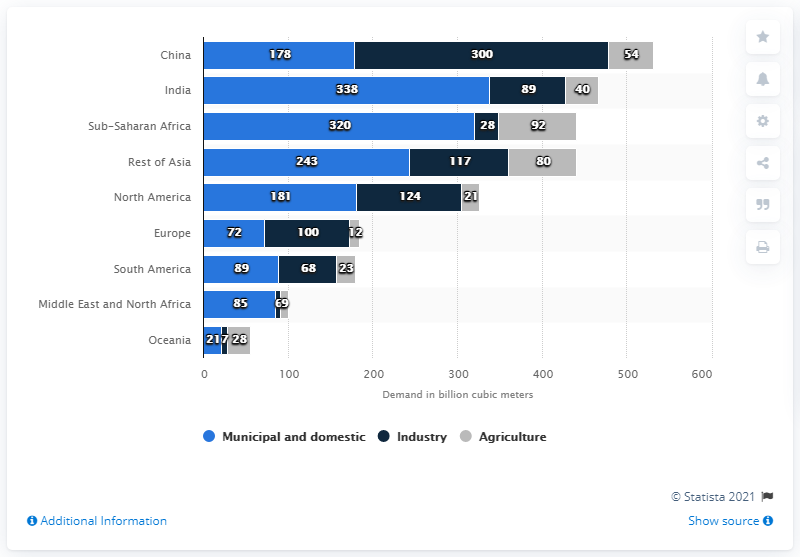Draw attention to some important aspects in this diagram. In 2015, 92% of the world's population had access to improved drinking water sources. By 2030, it is expected that the European industry will require an additional 100 units of water. 